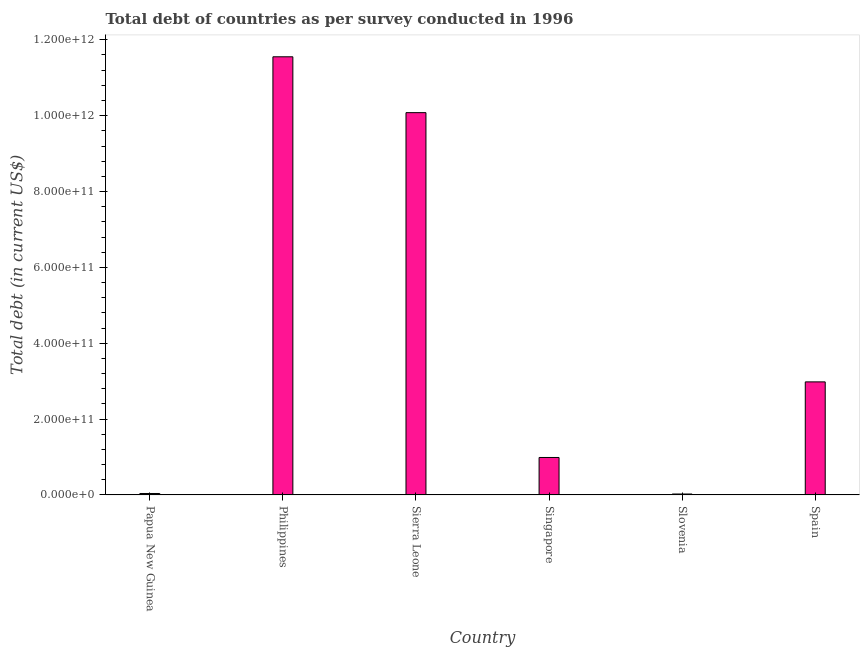Does the graph contain grids?
Your response must be concise. No. What is the title of the graph?
Ensure brevity in your answer.  Total debt of countries as per survey conducted in 1996. What is the label or title of the Y-axis?
Your answer should be compact. Total debt (in current US$). What is the total debt in Papua New Guinea?
Ensure brevity in your answer.  3.78e+09. Across all countries, what is the maximum total debt?
Give a very brief answer. 1.16e+12. Across all countries, what is the minimum total debt?
Make the answer very short. 2.42e+09. In which country was the total debt minimum?
Offer a terse response. Slovenia. What is the sum of the total debt?
Your response must be concise. 2.57e+12. What is the difference between the total debt in Philippines and Singapore?
Your answer should be compact. 1.06e+12. What is the average total debt per country?
Offer a very short reply. 4.28e+11. What is the median total debt?
Your response must be concise. 1.98e+11. What is the ratio of the total debt in Philippines to that in Slovenia?
Offer a terse response. 476.74. What is the difference between the highest and the second highest total debt?
Ensure brevity in your answer.  1.47e+11. Is the sum of the total debt in Singapore and Slovenia greater than the maximum total debt across all countries?
Make the answer very short. No. What is the difference between the highest and the lowest total debt?
Offer a terse response. 1.15e+12. In how many countries, is the total debt greater than the average total debt taken over all countries?
Ensure brevity in your answer.  2. How many countries are there in the graph?
Your answer should be very brief. 6. What is the difference between two consecutive major ticks on the Y-axis?
Provide a short and direct response. 2.00e+11. Are the values on the major ticks of Y-axis written in scientific E-notation?
Your answer should be compact. Yes. What is the Total debt (in current US$) of Papua New Guinea?
Offer a terse response. 3.78e+09. What is the Total debt (in current US$) of Philippines?
Ensure brevity in your answer.  1.16e+12. What is the Total debt (in current US$) in Sierra Leone?
Provide a succinct answer. 1.01e+12. What is the Total debt (in current US$) in Singapore?
Make the answer very short. 9.88e+1. What is the Total debt (in current US$) of Slovenia?
Ensure brevity in your answer.  2.42e+09. What is the Total debt (in current US$) in Spain?
Keep it short and to the point. 2.98e+11. What is the difference between the Total debt (in current US$) in Papua New Guinea and Philippines?
Provide a succinct answer. -1.15e+12. What is the difference between the Total debt (in current US$) in Papua New Guinea and Sierra Leone?
Make the answer very short. -1.00e+12. What is the difference between the Total debt (in current US$) in Papua New Guinea and Singapore?
Ensure brevity in your answer.  -9.50e+1. What is the difference between the Total debt (in current US$) in Papua New Guinea and Slovenia?
Your answer should be very brief. 1.36e+09. What is the difference between the Total debt (in current US$) in Papua New Guinea and Spain?
Give a very brief answer. -2.94e+11. What is the difference between the Total debt (in current US$) in Philippines and Sierra Leone?
Your response must be concise. 1.47e+11. What is the difference between the Total debt (in current US$) in Philippines and Singapore?
Make the answer very short. 1.06e+12. What is the difference between the Total debt (in current US$) in Philippines and Slovenia?
Your answer should be very brief. 1.15e+12. What is the difference between the Total debt (in current US$) in Philippines and Spain?
Your response must be concise. 8.57e+11. What is the difference between the Total debt (in current US$) in Sierra Leone and Singapore?
Your answer should be very brief. 9.09e+11. What is the difference between the Total debt (in current US$) in Sierra Leone and Slovenia?
Your answer should be very brief. 1.01e+12. What is the difference between the Total debt (in current US$) in Sierra Leone and Spain?
Your answer should be very brief. 7.10e+11. What is the difference between the Total debt (in current US$) in Singapore and Slovenia?
Keep it short and to the point. 9.63e+1. What is the difference between the Total debt (in current US$) in Singapore and Spain?
Give a very brief answer. -1.99e+11. What is the difference between the Total debt (in current US$) in Slovenia and Spain?
Ensure brevity in your answer.  -2.96e+11. What is the ratio of the Total debt (in current US$) in Papua New Guinea to that in Philippines?
Offer a terse response. 0. What is the ratio of the Total debt (in current US$) in Papua New Guinea to that in Sierra Leone?
Give a very brief answer. 0. What is the ratio of the Total debt (in current US$) in Papua New Guinea to that in Singapore?
Offer a terse response. 0.04. What is the ratio of the Total debt (in current US$) in Papua New Guinea to that in Slovenia?
Provide a succinct answer. 1.56. What is the ratio of the Total debt (in current US$) in Papua New Guinea to that in Spain?
Your answer should be very brief. 0.01. What is the ratio of the Total debt (in current US$) in Philippines to that in Sierra Leone?
Offer a terse response. 1.15. What is the ratio of the Total debt (in current US$) in Philippines to that in Singapore?
Your response must be concise. 11.7. What is the ratio of the Total debt (in current US$) in Philippines to that in Slovenia?
Your response must be concise. 476.74. What is the ratio of the Total debt (in current US$) in Philippines to that in Spain?
Your answer should be very brief. 3.88. What is the ratio of the Total debt (in current US$) in Sierra Leone to that in Singapore?
Your answer should be very brief. 10.21. What is the ratio of the Total debt (in current US$) in Sierra Leone to that in Slovenia?
Keep it short and to the point. 415.95. What is the ratio of the Total debt (in current US$) in Sierra Leone to that in Spain?
Keep it short and to the point. 3.38. What is the ratio of the Total debt (in current US$) in Singapore to that in Slovenia?
Provide a succinct answer. 40.76. What is the ratio of the Total debt (in current US$) in Singapore to that in Spain?
Keep it short and to the point. 0.33. What is the ratio of the Total debt (in current US$) in Slovenia to that in Spain?
Ensure brevity in your answer.  0.01. 